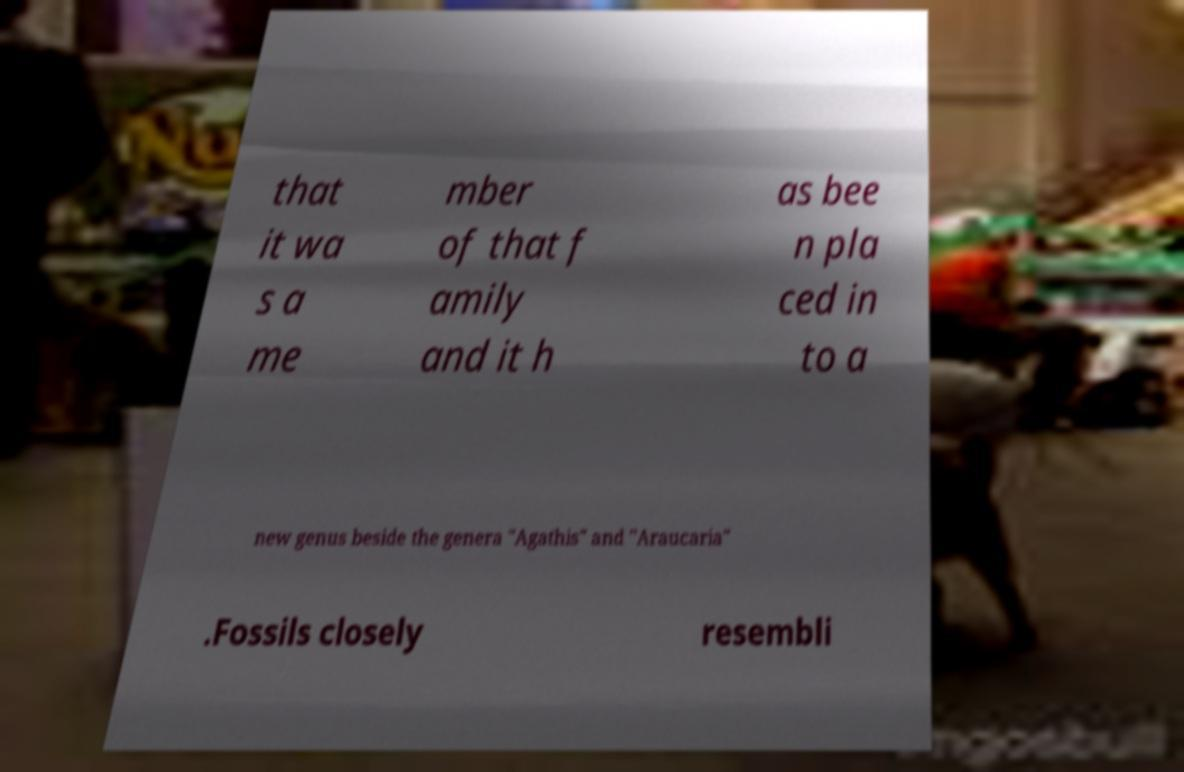Please read and relay the text visible in this image. What does it say? that it wa s a me mber of that f amily and it h as bee n pla ced in to a new genus beside the genera "Agathis" and "Araucaria" .Fossils closely resembli 